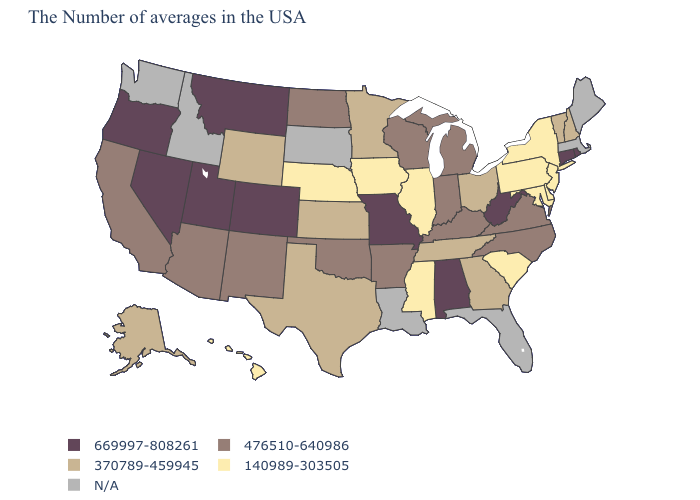What is the highest value in states that border Delaware?
Quick response, please. 140989-303505. What is the highest value in states that border Montana?
Give a very brief answer. 476510-640986. Name the states that have a value in the range 669997-808261?
Give a very brief answer. Rhode Island, Connecticut, West Virginia, Alabama, Missouri, Colorado, Utah, Montana, Nevada, Oregon. What is the value of South Carolina?
Quick response, please. 140989-303505. Does Hawaii have the lowest value in the West?
Concise answer only. Yes. What is the value of Colorado?
Answer briefly. 669997-808261. How many symbols are there in the legend?
Short answer required. 5. What is the highest value in the South ?
Give a very brief answer. 669997-808261. Does the map have missing data?
Keep it brief. Yes. Does the map have missing data?
Give a very brief answer. Yes. Name the states that have a value in the range 140989-303505?
Give a very brief answer. New York, New Jersey, Delaware, Maryland, Pennsylvania, South Carolina, Illinois, Mississippi, Iowa, Nebraska, Hawaii. What is the lowest value in the USA?
Write a very short answer. 140989-303505. Does Maryland have the lowest value in the USA?
Short answer required. Yes. Among the states that border Michigan , does Ohio have the highest value?
Short answer required. No. What is the lowest value in states that border New Mexico?
Short answer required. 370789-459945. 